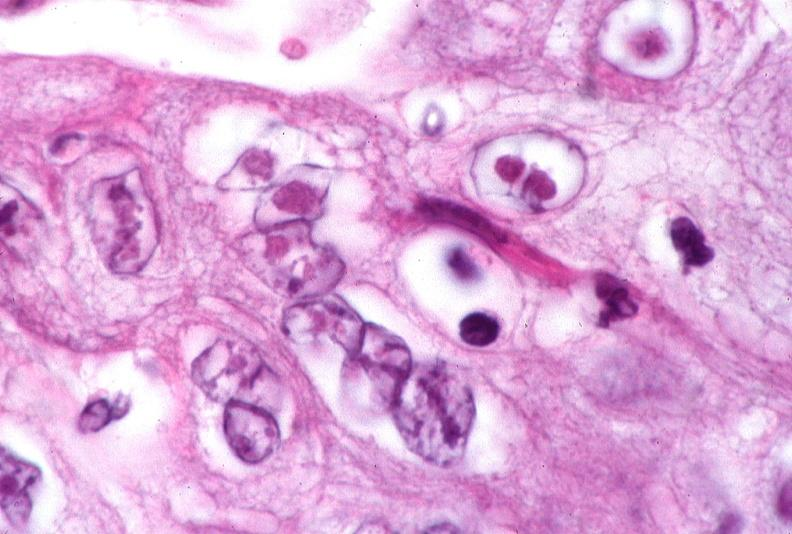what does this image show?
Answer the question using a single word or phrase. Skin 